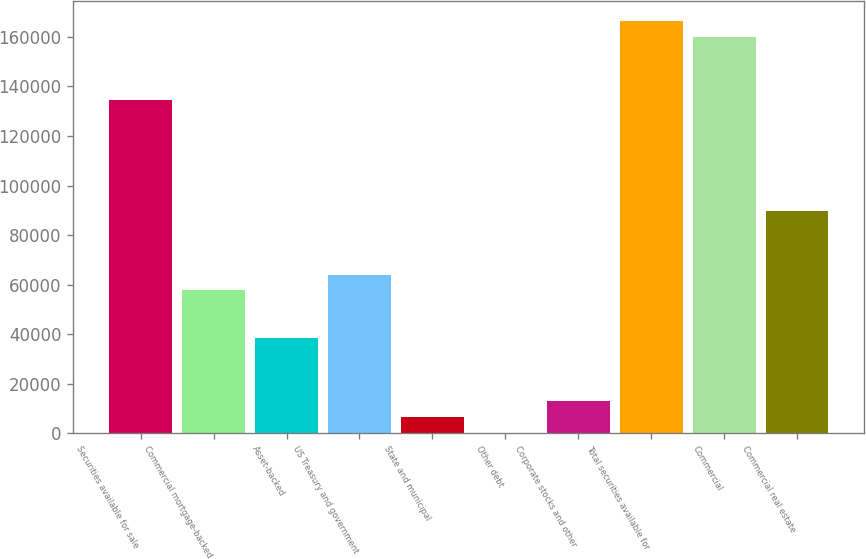Convert chart. <chart><loc_0><loc_0><loc_500><loc_500><bar_chart><fcel>Securities available for sale<fcel>Commercial mortgage-backed<fcel>Asset-backed<fcel>US Treasury and government<fcel>State and municipal<fcel>Other debt<fcel>Corporate stocks and other<fcel>Total securities available for<fcel>Commercial<fcel>Commercial real estate<nl><fcel>134369<fcel>57637.7<fcel>38454.8<fcel>64032<fcel>6483.3<fcel>89<fcel>12877.6<fcel>166341<fcel>159946<fcel>89609.2<nl></chart> 